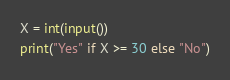<code> <loc_0><loc_0><loc_500><loc_500><_Python_>X = int(input())
print("Yes" if X >= 30 else "No")</code> 